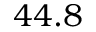Convert formula to latex. <formula><loc_0><loc_0><loc_500><loc_500>4 4 . 8</formula> 